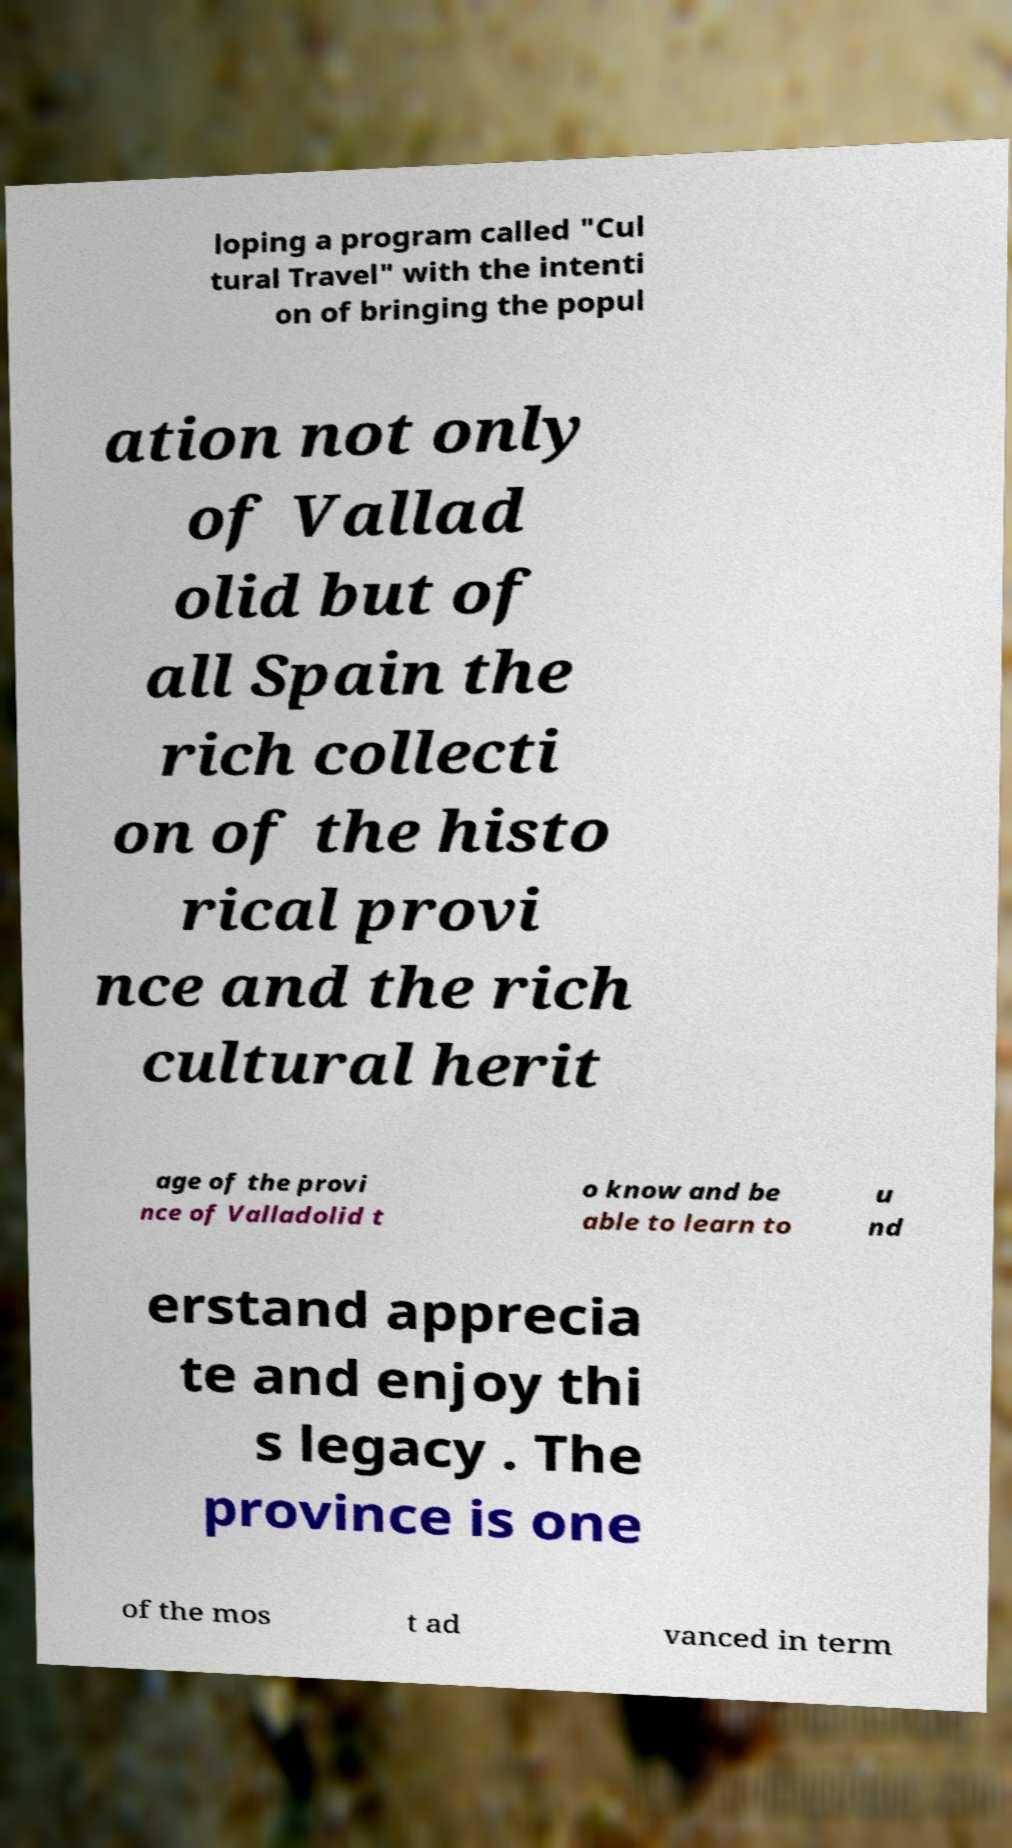Can you read and provide the text displayed in the image?This photo seems to have some interesting text. Can you extract and type it out for me? loping a program called "Cul tural Travel" with the intenti on of bringing the popul ation not only of Vallad olid but of all Spain the rich collecti on of the histo rical provi nce and the rich cultural herit age of the provi nce of Valladolid t o know and be able to learn to u nd erstand apprecia te and enjoy thi s legacy . The province is one of the mos t ad vanced in term 